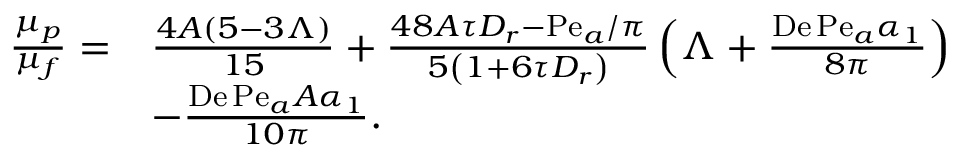Convert formula to latex. <formula><loc_0><loc_0><loc_500><loc_500>\begin{array} { r l } { \frac { \mu _ { p } } { \mu _ { f } } = } & { \frac { 4 A ( 5 - 3 \Lambda ) } { 1 5 } + \frac { 4 8 A \tau D _ { r } - P e _ { a } / \pi } { 5 \left ( 1 + 6 \tau D _ { r } \right ) } \left ( \Lambda + \frac { D e \, P e _ { a } \alpha _ { 1 } } { 8 \pi } \right ) } \\ & { - \frac { D e \, P e _ { a } A \alpha _ { 1 } } { 1 0 \pi } . } \end{array}</formula> 